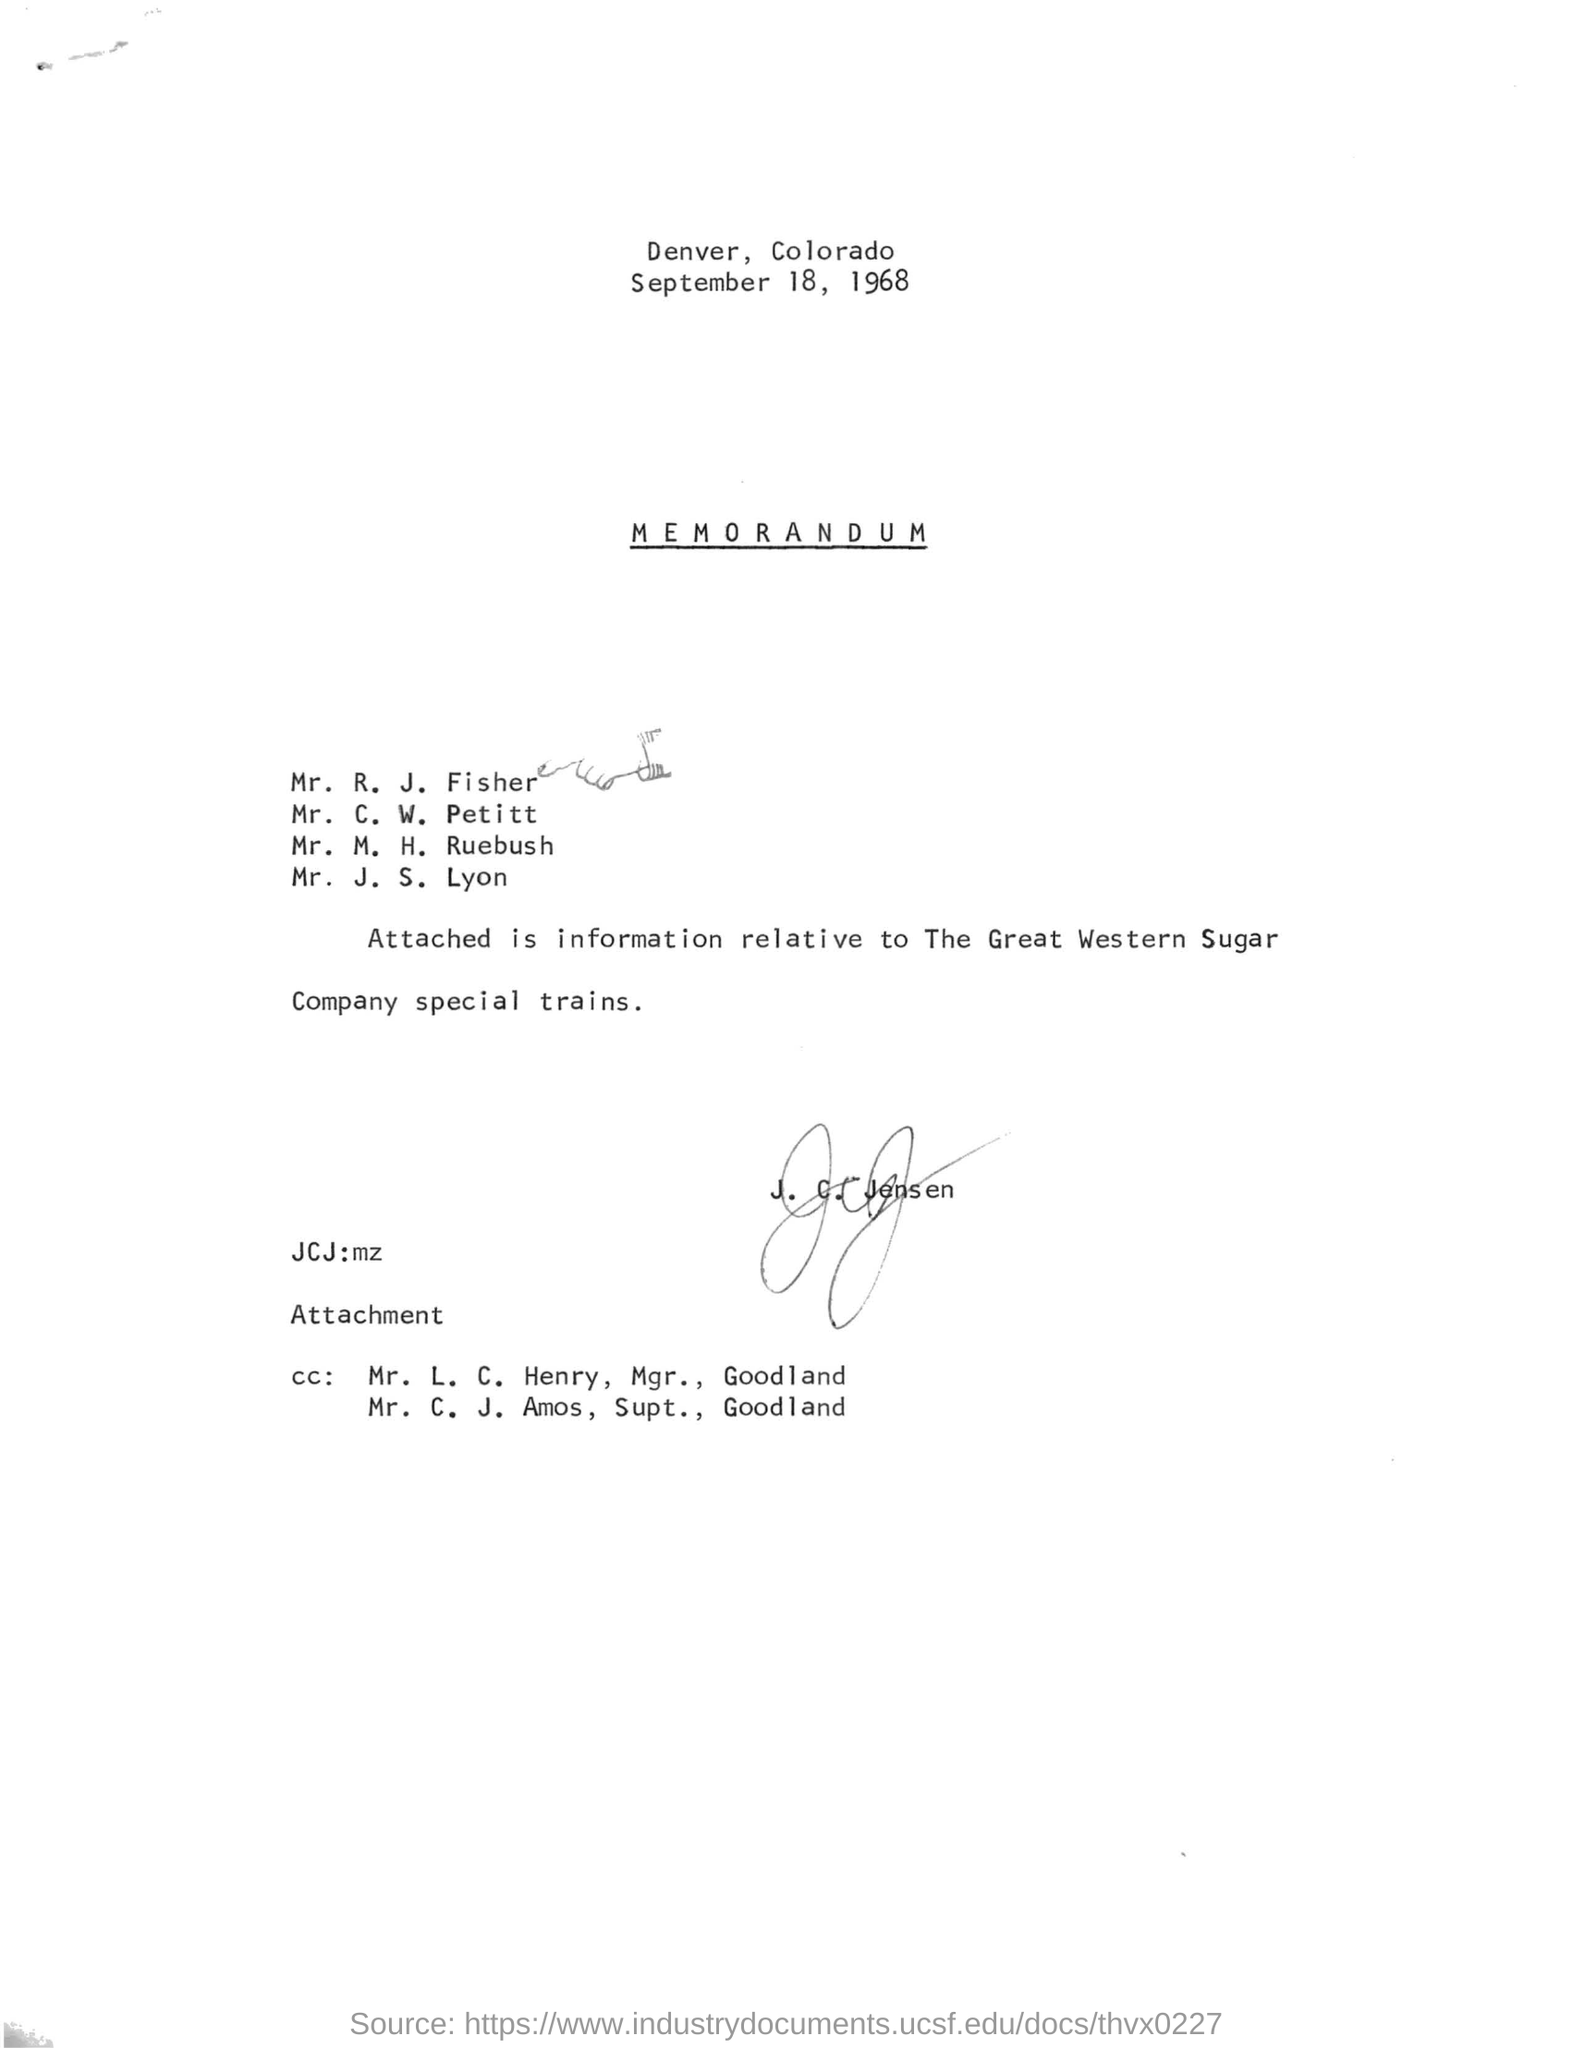Highlight a few significant elements in this photo. The memorandum dated September 18, 1968, is asking for approval for an upcoming event. 